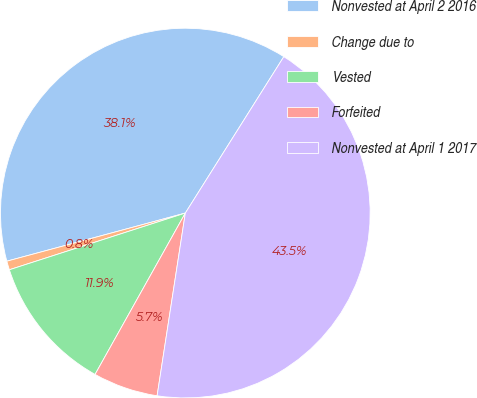Convert chart to OTSL. <chart><loc_0><loc_0><loc_500><loc_500><pie_chart><fcel>Nonvested at April 2 2016<fcel>Change due to<fcel>Vested<fcel>Forfeited<fcel>Nonvested at April 1 2017<nl><fcel>38.13%<fcel>0.77%<fcel>11.92%<fcel>5.68%<fcel>43.49%<nl></chart> 